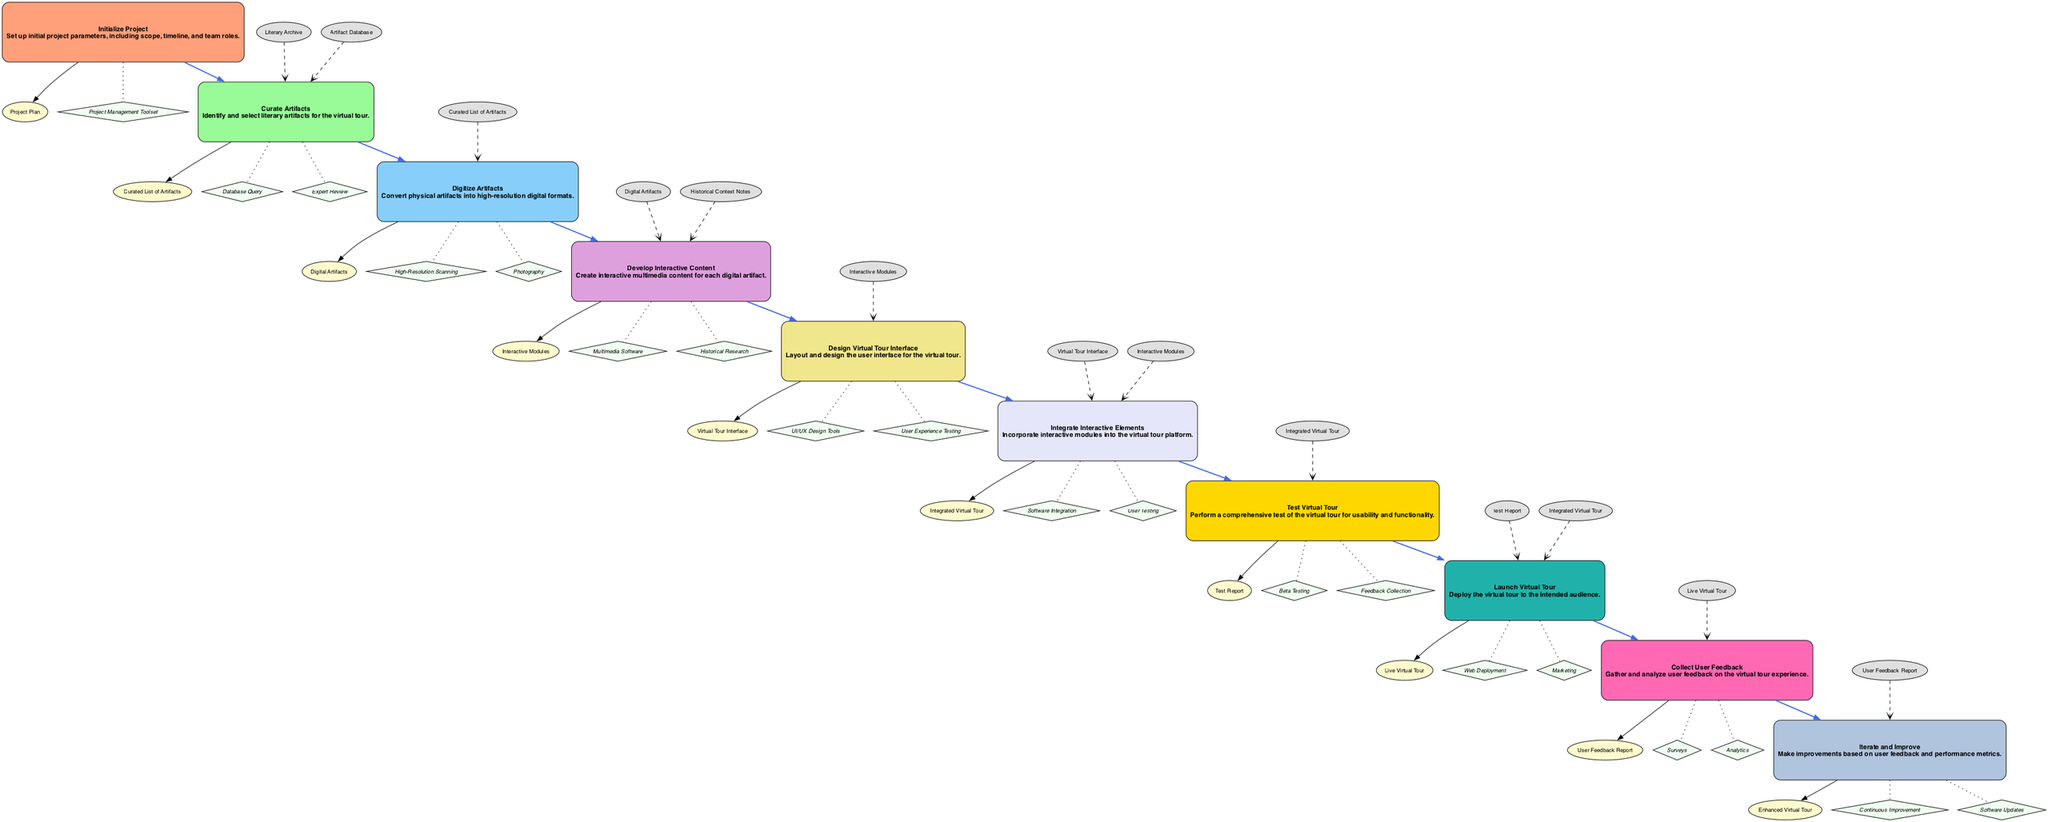What is the first step in developing the tour? The first step as indicated in the diagram is "Initialize Project". This node outlines the initial setup requirements for the project.
Answer: Initialize Project How many outputs does the "Curate Artifacts" step have? The "Curate Artifacts" step has one output listed in the diagram, which is "Curated List of Artifacts".
Answer: 1 What is the output of the "Test Virtual Tour"? The output indicated for "Test Virtual Tour" in the diagram is "Test Report". This is the result of testing the integrated virtual tour for usability and functionality.
Answer: Test Report Which method is used to create interactive multimedia content? The method used for creating interactive multimedia content, as shown in the "Develop Interactive Content" node, is "Multimedia Software". This is critical for developing the content associated with each artifact.
Answer: Multimedia Software What are the inputs for the "Launch Virtual Tour" step? The inputs for the "Launch Virtual Tour" step are "Test Report" and "Integrated Virtual Tour". This indicates that both the testing feedback and the integrated product are necessary for launch.
Answer: Test Report, Integrated Virtual Tour What is the output of the "Iterate and Improve" function? The output specified in the "Iterate and Improve" function is "Enhanced Virtual Tour", which reflects subsequent improvements made based on feedback.
Answer: Enhanced Virtual Tour What connects "Digitize Artifacts" to "Develop Interactive Content"? The connection between "Digitize Artifacts" and "Develop Interactive Content" is established through the output "Digital Artifacts". This shows that the completion of digitizing is essential for creating interactive content.
Answer: Digital Artifacts How many methods are listed for the "Design Virtual Tour Interface"? There are two methods listed for "Design Virtual Tour Interface" in the diagram: "UI/UX Design Tools" and "User Experience Testing". This indicates a dual approach in the design process.
Answer: 2 What step follows "Integrate Interactive Elements"? The step that directly follows "Integrate Interactive Elements" is "Test Virtual Tour". This represents the workflow where integration is followed by usability testing.
Answer: Test Virtual Tour 